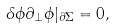<formula> <loc_0><loc_0><loc_500><loc_500>\delta \phi \partial _ { \perp } \phi | _ { \partial \Sigma } & = 0 ,</formula> 